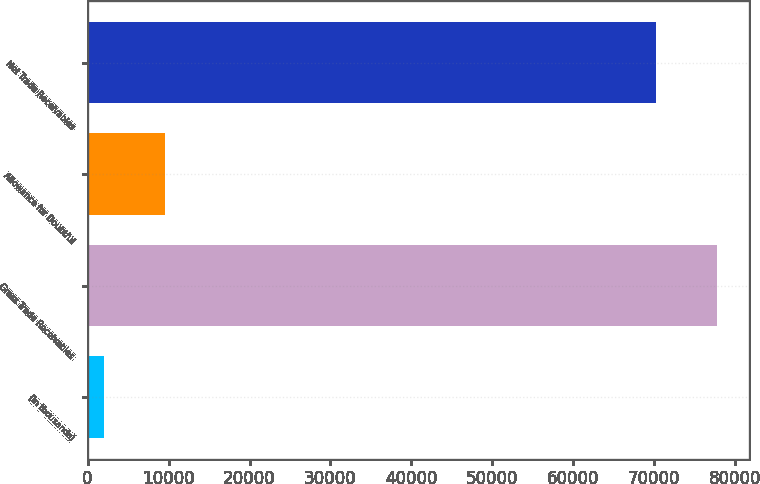<chart> <loc_0><loc_0><loc_500><loc_500><bar_chart><fcel>(in thousands)<fcel>Gross Trade Receivables<fcel>Allowance for Doubtful<fcel>Net Trade Receivables<nl><fcel>2008<fcel>77765.4<fcel>9580.4<fcel>70193<nl></chart> 